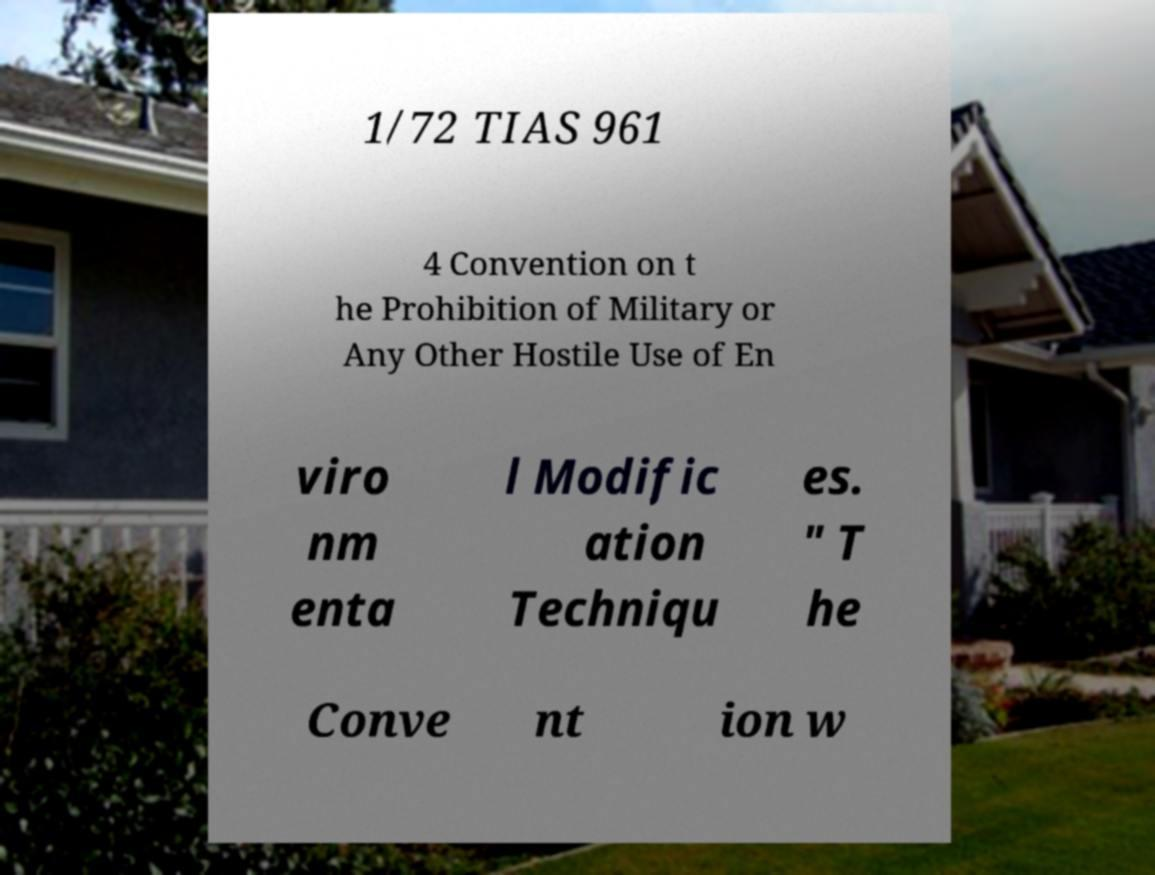Could you assist in decoding the text presented in this image and type it out clearly? 1/72 TIAS 961 4 Convention on t he Prohibition of Military or Any Other Hostile Use of En viro nm enta l Modific ation Techniqu es. " T he Conve nt ion w 